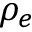Convert formula to latex. <formula><loc_0><loc_0><loc_500><loc_500>\rho _ { e }</formula> 